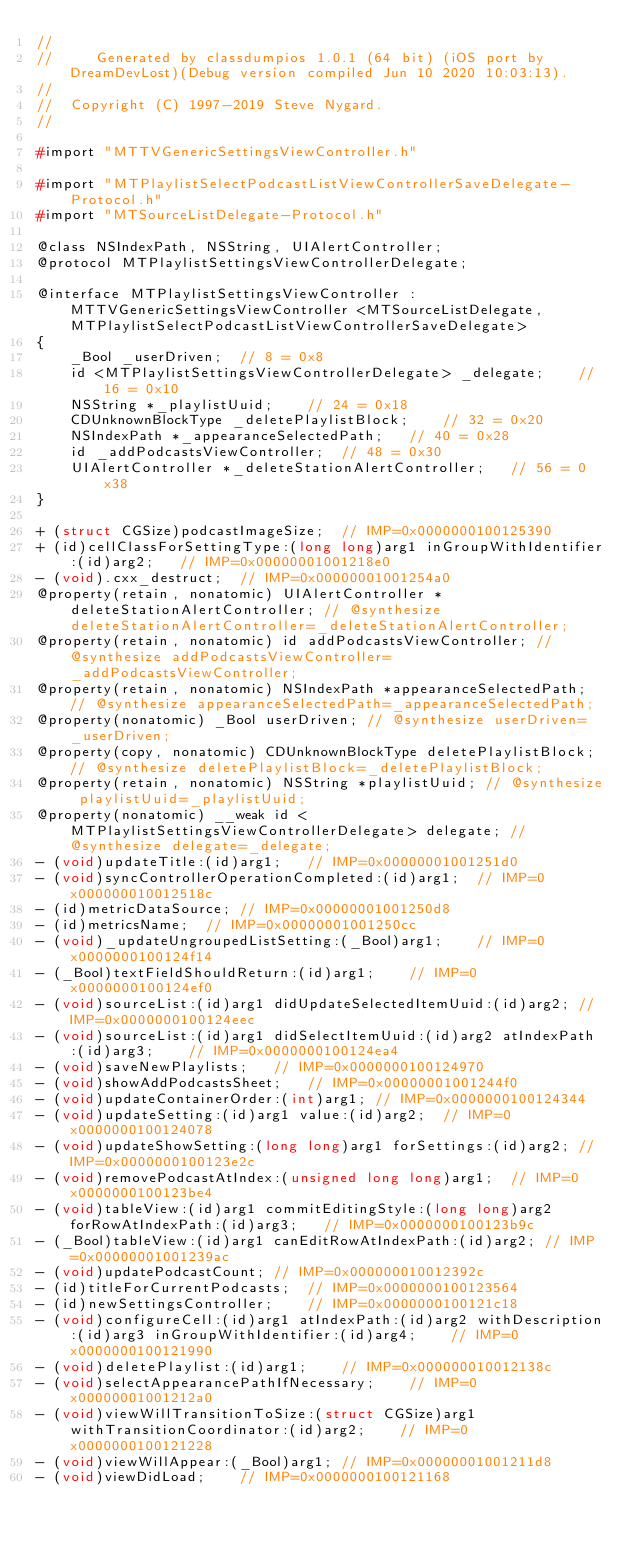<code> <loc_0><loc_0><loc_500><loc_500><_C_>//
//     Generated by classdumpios 1.0.1 (64 bit) (iOS port by DreamDevLost)(Debug version compiled Jun 10 2020 10:03:13).
//
//  Copyright (C) 1997-2019 Steve Nygard.
//

#import "MTTVGenericSettingsViewController.h"

#import "MTPlaylistSelectPodcastListViewControllerSaveDelegate-Protocol.h"
#import "MTSourceListDelegate-Protocol.h"

@class NSIndexPath, NSString, UIAlertController;
@protocol MTPlaylistSettingsViewControllerDelegate;

@interface MTPlaylistSettingsViewController : MTTVGenericSettingsViewController <MTSourceListDelegate, MTPlaylistSelectPodcastListViewControllerSaveDelegate>
{
    _Bool _userDriven;	// 8 = 0x8
    id <MTPlaylistSettingsViewControllerDelegate> _delegate;	// 16 = 0x10
    NSString *_playlistUuid;	// 24 = 0x18
    CDUnknownBlockType _deletePlaylistBlock;	// 32 = 0x20
    NSIndexPath *_appearanceSelectedPath;	// 40 = 0x28
    id _addPodcastsViewController;	// 48 = 0x30
    UIAlertController *_deleteStationAlertController;	// 56 = 0x38
}

+ (struct CGSize)podcastImageSize;	// IMP=0x0000000100125390
+ (id)cellClassForSettingType:(long long)arg1 inGroupWithIdentifier:(id)arg2;	// IMP=0x00000001001218e0
- (void).cxx_destruct;	// IMP=0x00000001001254a0
@property(retain, nonatomic) UIAlertController *deleteStationAlertController; // @synthesize deleteStationAlertController=_deleteStationAlertController;
@property(retain, nonatomic) id addPodcastsViewController; // @synthesize addPodcastsViewController=_addPodcastsViewController;
@property(retain, nonatomic) NSIndexPath *appearanceSelectedPath; // @synthesize appearanceSelectedPath=_appearanceSelectedPath;
@property(nonatomic) _Bool userDriven; // @synthesize userDriven=_userDriven;
@property(copy, nonatomic) CDUnknownBlockType deletePlaylistBlock; // @synthesize deletePlaylistBlock=_deletePlaylistBlock;
@property(retain, nonatomic) NSString *playlistUuid; // @synthesize playlistUuid=_playlistUuid;
@property(nonatomic) __weak id <MTPlaylistSettingsViewControllerDelegate> delegate; // @synthesize delegate=_delegate;
- (void)updateTitle:(id)arg1;	// IMP=0x00000001001251d0
- (void)syncControllerOperationCompleted:(id)arg1;	// IMP=0x000000010012518c
- (id)metricDataSource;	// IMP=0x00000001001250d8
- (id)metricsName;	// IMP=0x00000001001250cc
- (void)_updateUngroupedListSetting:(_Bool)arg1;	// IMP=0x0000000100124f14
- (_Bool)textFieldShouldReturn:(id)arg1;	// IMP=0x0000000100124ef0
- (void)sourceList:(id)arg1 didUpdateSelectedItemUuid:(id)arg2;	// IMP=0x0000000100124eec
- (void)sourceList:(id)arg1 didSelectItemUuid:(id)arg2 atIndexPath:(id)arg3;	// IMP=0x0000000100124ea4
- (void)saveNewPlaylists;	// IMP=0x0000000100124970
- (void)showAddPodcastsSheet;	// IMP=0x00000001001244f0
- (void)updateContainerOrder:(int)arg1;	// IMP=0x0000000100124344
- (void)updateSetting:(id)arg1 value:(id)arg2;	// IMP=0x0000000100124078
- (void)updateShowSetting:(long long)arg1 forSettings:(id)arg2;	// IMP=0x0000000100123e2c
- (void)removePodcastAtIndex:(unsigned long long)arg1;	// IMP=0x0000000100123be4
- (void)tableView:(id)arg1 commitEditingStyle:(long long)arg2 forRowAtIndexPath:(id)arg3;	// IMP=0x0000000100123b9c
- (_Bool)tableView:(id)arg1 canEditRowAtIndexPath:(id)arg2;	// IMP=0x00000001001239ac
- (void)updatePodcastCount;	// IMP=0x000000010012392c
- (id)titleForCurrentPodcasts;	// IMP=0x0000000100123564
- (id)newSettingsController;	// IMP=0x0000000100121c18
- (void)configureCell:(id)arg1 atIndexPath:(id)arg2 withDescription:(id)arg3 inGroupWithIdentifier:(id)arg4;	// IMP=0x0000000100121990
- (void)deletePlaylist:(id)arg1;	// IMP=0x000000010012138c
- (void)selectAppearancePathIfNecessary;	// IMP=0x00000001001212a0
- (void)viewWillTransitionToSize:(struct CGSize)arg1 withTransitionCoordinator:(id)arg2;	// IMP=0x0000000100121228
- (void)viewWillAppear:(_Bool)arg1;	// IMP=0x00000001001211d8
- (void)viewDidLoad;	// IMP=0x0000000100121168</code> 